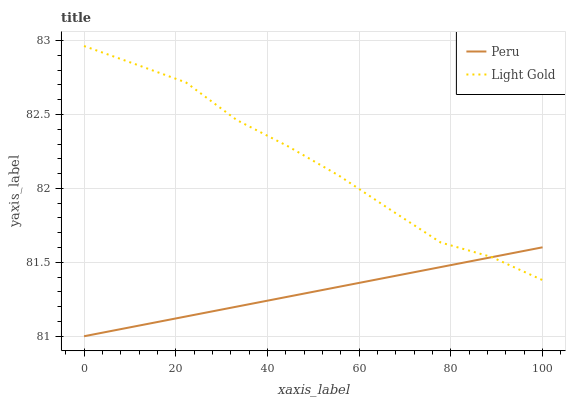Does Peru have the minimum area under the curve?
Answer yes or no. Yes. Does Light Gold have the maximum area under the curve?
Answer yes or no. Yes. Does Peru have the maximum area under the curve?
Answer yes or no. No. Is Peru the smoothest?
Answer yes or no. Yes. Is Light Gold the roughest?
Answer yes or no. Yes. Is Peru the roughest?
Answer yes or no. No. Does Peru have the lowest value?
Answer yes or no. Yes. Does Light Gold have the highest value?
Answer yes or no. Yes. Does Peru have the highest value?
Answer yes or no. No. Does Light Gold intersect Peru?
Answer yes or no. Yes. Is Light Gold less than Peru?
Answer yes or no. No. Is Light Gold greater than Peru?
Answer yes or no. No. 